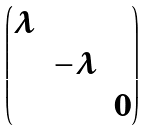<formula> <loc_0><loc_0><loc_500><loc_500>\begin{pmatrix} \lambda \\ & - \lambda \\ & & 0 \end{pmatrix}</formula> 